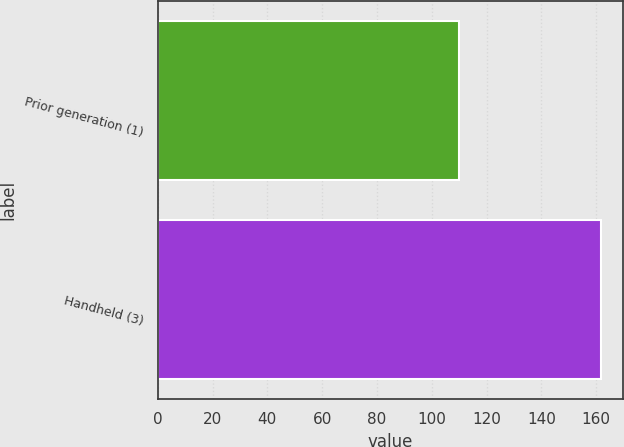Convert chart. <chart><loc_0><loc_0><loc_500><loc_500><bar_chart><fcel>Prior generation (1)<fcel>Handheld (3)<nl><fcel>110.1<fcel>161.8<nl></chart> 